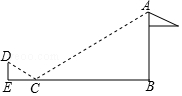First perform reasoning, then finally select the question from the choices in the following format: Answer: xxx.
Question: As shown in the figure, in order to measure the height of the flagpole AB, Xiaofan placed a mirror at point C from the bottom of the flagpole B point 10.8. When Xiaofan walks to the point E, which is in the same straight line as BC, he can observe from the mirror. Go to point A on the top of the flagpole. Knowing that the height of point D where Xiaofan's eyes are from the ground is 1.6, CE = 2.7, then the height of the flagpole AB is ()
Choices:
A: 6.4米
B: 7.2米
C: 8米
D: 9.6米 Solution: The normal line CH to the mirror is drawn through point C. According to the optical principle, we have angle DCH = angle ACH. Since angle DCE = 90° - angle DCH and angle ACB = 90° - angle ACH, we have angle DCE = angle ACB. Also, since angle DEC = angle ABC = 90°, we have triangle CDE similar  triangle CAB. Therefore,  DE / AB = CE / CB, which means 1.6 / AB = 2.7 / 10.8. Solving for AB, we get AB = 6.4 (m). Answer: The height of the flagpole AB is 6.4 meters. So the answer is A.
Answer:A 